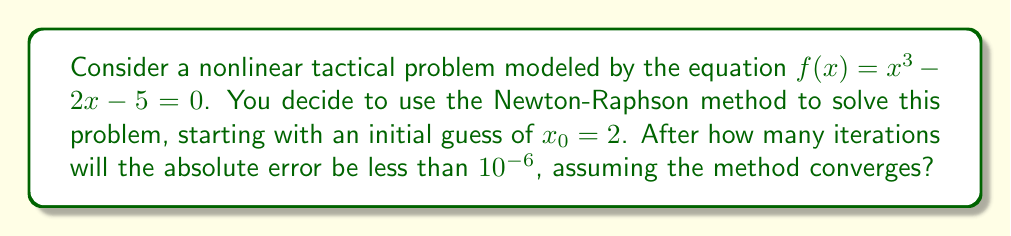Give your solution to this math problem. Let's approach this step-by-step:

1) The Newton-Raphson method is given by the formula:

   $x_{n+1} = x_n - \frac{f(x_n)}{f'(x_n)}$

2) For our function $f(x) = x^3 - 2x - 5$, we have $f'(x) = 3x^2 - 2$

3) Let's calculate the first few iterations:

   Iteration 0: $x_0 = 2$
   
   Iteration 1: $x_1 = 2 - \frac{2^3 - 2(2) - 5}{3(2)^2 - 2} = 2 - \frac{-1}{10} = 2.1$
   
   Iteration 2: $x_2 = 2.1 - \frac{2.1^3 - 2(2.1) - 5}{3(2.1)^2 - 2} \approx 2.09455148$
   
   Iteration 3: $x_3 \approx 2.09455148 - \frac{2.09455148^3 - 2(2.09455148) - 5}{3(2.09455148)^2 - 2} \approx 2.09455148$

4) We can see that the method converges quickly. To determine when the absolute error is less than $10^{-6}$, we need to compare successive iterations:

   $|x_3 - x_2| \approx 1.37 \times 10^{-8} < 10^{-6}$

5) Therefore, after 3 iterations, the absolute error is already less than $10^{-6}$.

This rapid convergence is characteristic of the Newton-Raphson method when the initial guess is close to the root and the function is well-behaved near the root.
Answer: 3 iterations 